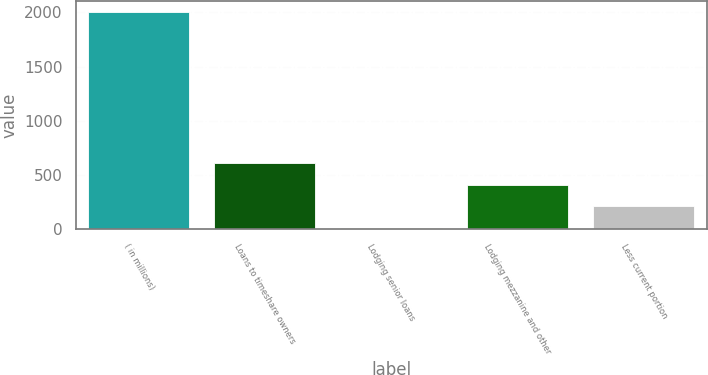Convert chart. <chart><loc_0><loc_0><loc_500><loc_500><bar_chart><fcel>( in millions)<fcel>Loans to timeshare owners<fcel>Lodging senior loans<fcel>Lodging mezzanine and other<fcel>Less current portion<nl><fcel>2006<fcel>608.1<fcel>9<fcel>408.4<fcel>208.7<nl></chart> 